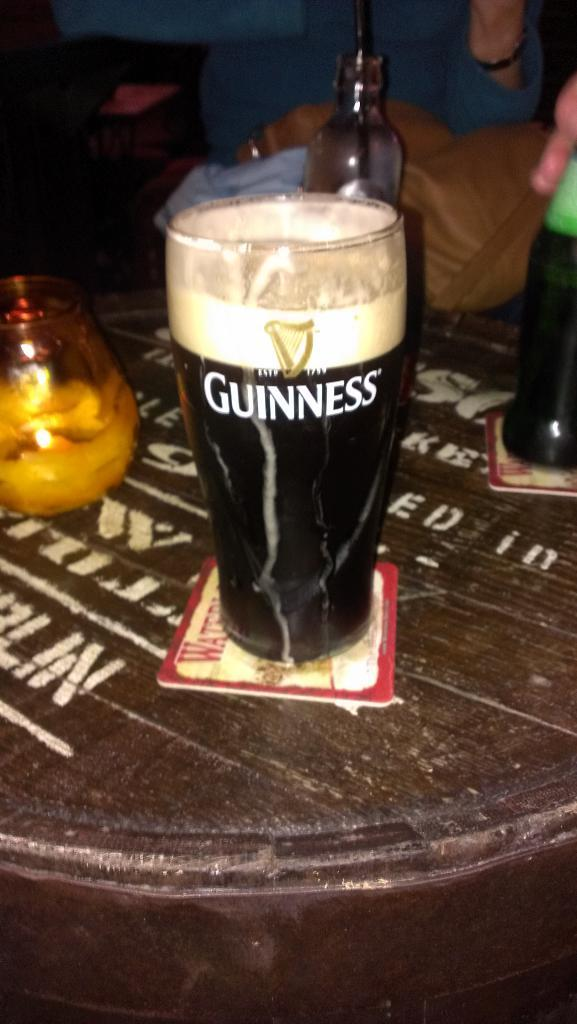<image>
Summarize the visual content of the image. a glall of brown guinness beer on a round table 